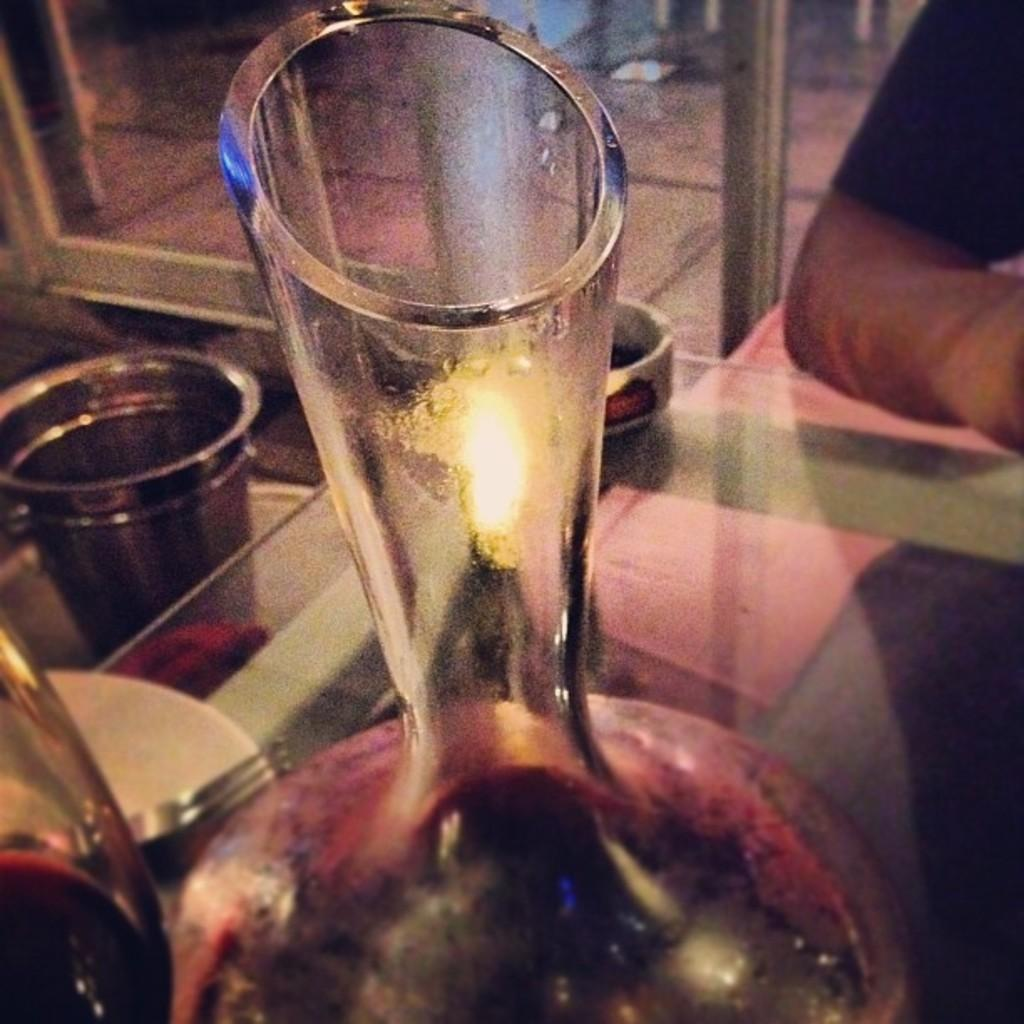What objects are placed on the table in the image? There are glasses placed on a table in the image. What material is the table made of? The table is made of glass. Can you describe any other elements in the image? A person's hand is visible in the image. Where is the drawer located in the image? There is no drawer present in the image. Can you hear a whistle in the image? There is no whistle present in the image, and therefore no sound can be heard. 